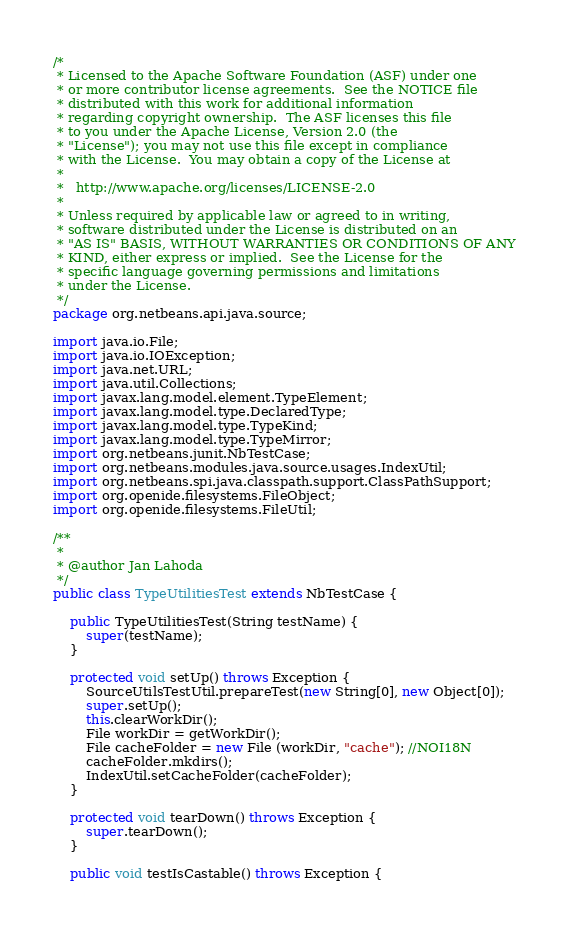<code> <loc_0><loc_0><loc_500><loc_500><_Java_>/*
 * Licensed to the Apache Software Foundation (ASF) under one
 * or more contributor license agreements.  See the NOTICE file
 * distributed with this work for additional information
 * regarding copyright ownership.  The ASF licenses this file
 * to you under the Apache License, Version 2.0 (the
 * "License"); you may not use this file except in compliance
 * with the License.  You may obtain a copy of the License at
 *
 *   http://www.apache.org/licenses/LICENSE-2.0
 *
 * Unless required by applicable law or agreed to in writing,
 * software distributed under the License is distributed on an
 * "AS IS" BASIS, WITHOUT WARRANTIES OR CONDITIONS OF ANY
 * KIND, either express or implied.  See the License for the
 * specific language governing permissions and limitations
 * under the License.
 */
package org.netbeans.api.java.source;

import java.io.File;
import java.io.IOException;
import java.net.URL;
import java.util.Collections;
import javax.lang.model.element.TypeElement;
import javax.lang.model.type.DeclaredType;
import javax.lang.model.type.TypeKind;
import javax.lang.model.type.TypeMirror;
import org.netbeans.junit.NbTestCase;
import org.netbeans.modules.java.source.usages.IndexUtil;
import org.netbeans.spi.java.classpath.support.ClassPathSupport;
import org.openide.filesystems.FileObject;
import org.openide.filesystems.FileUtil;

/**
 *
 * @author Jan Lahoda
 */
public class TypeUtilitiesTest extends NbTestCase {
    
    public TypeUtilitiesTest(String testName) {
        super(testName);
    }
    
    protected void setUp() throws Exception {
        SourceUtilsTestUtil.prepareTest(new String[0], new Object[0]);
        super.setUp();
        this.clearWorkDir();
        File workDir = getWorkDir();
        File cacheFolder = new File (workDir, "cache"); //NOI18N
        cacheFolder.mkdirs();
        IndexUtil.setCacheFolder(cacheFolder);
    }

    protected void tearDown() throws Exception {
        super.tearDown();
    }

    public void testIsCastable() throws Exception {</code> 